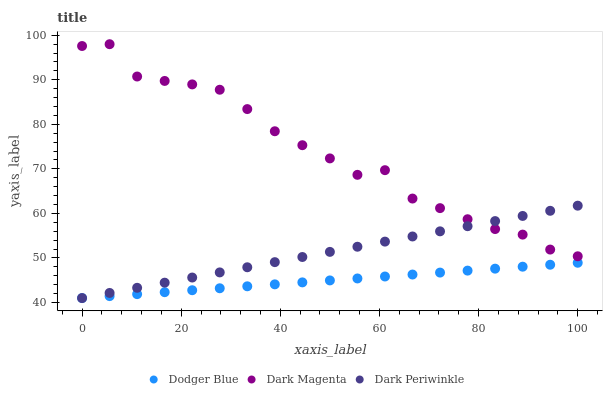Does Dodger Blue have the minimum area under the curve?
Answer yes or no. Yes. Does Dark Magenta have the maximum area under the curve?
Answer yes or no. Yes. Does Dark Periwinkle have the minimum area under the curve?
Answer yes or no. No. Does Dark Periwinkle have the maximum area under the curve?
Answer yes or no. No. Is Dark Periwinkle the smoothest?
Answer yes or no. Yes. Is Dark Magenta the roughest?
Answer yes or no. Yes. Is Dark Magenta the smoothest?
Answer yes or no. No. Is Dark Periwinkle the roughest?
Answer yes or no. No. Does Dodger Blue have the lowest value?
Answer yes or no. Yes. Does Dark Magenta have the lowest value?
Answer yes or no. No. Does Dark Magenta have the highest value?
Answer yes or no. Yes. Does Dark Periwinkle have the highest value?
Answer yes or no. No. Is Dodger Blue less than Dark Magenta?
Answer yes or no. Yes. Is Dark Magenta greater than Dodger Blue?
Answer yes or no. Yes. Does Dark Periwinkle intersect Dark Magenta?
Answer yes or no. Yes. Is Dark Periwinkle less than Dark Magenta?
Answer yes or no. No. Is Dark Periwinkle greater than Dark Magenta?
Answer yes or no. No. Does Dodger Blue intersect Dark Magenta?
Answer yes or no. No. 